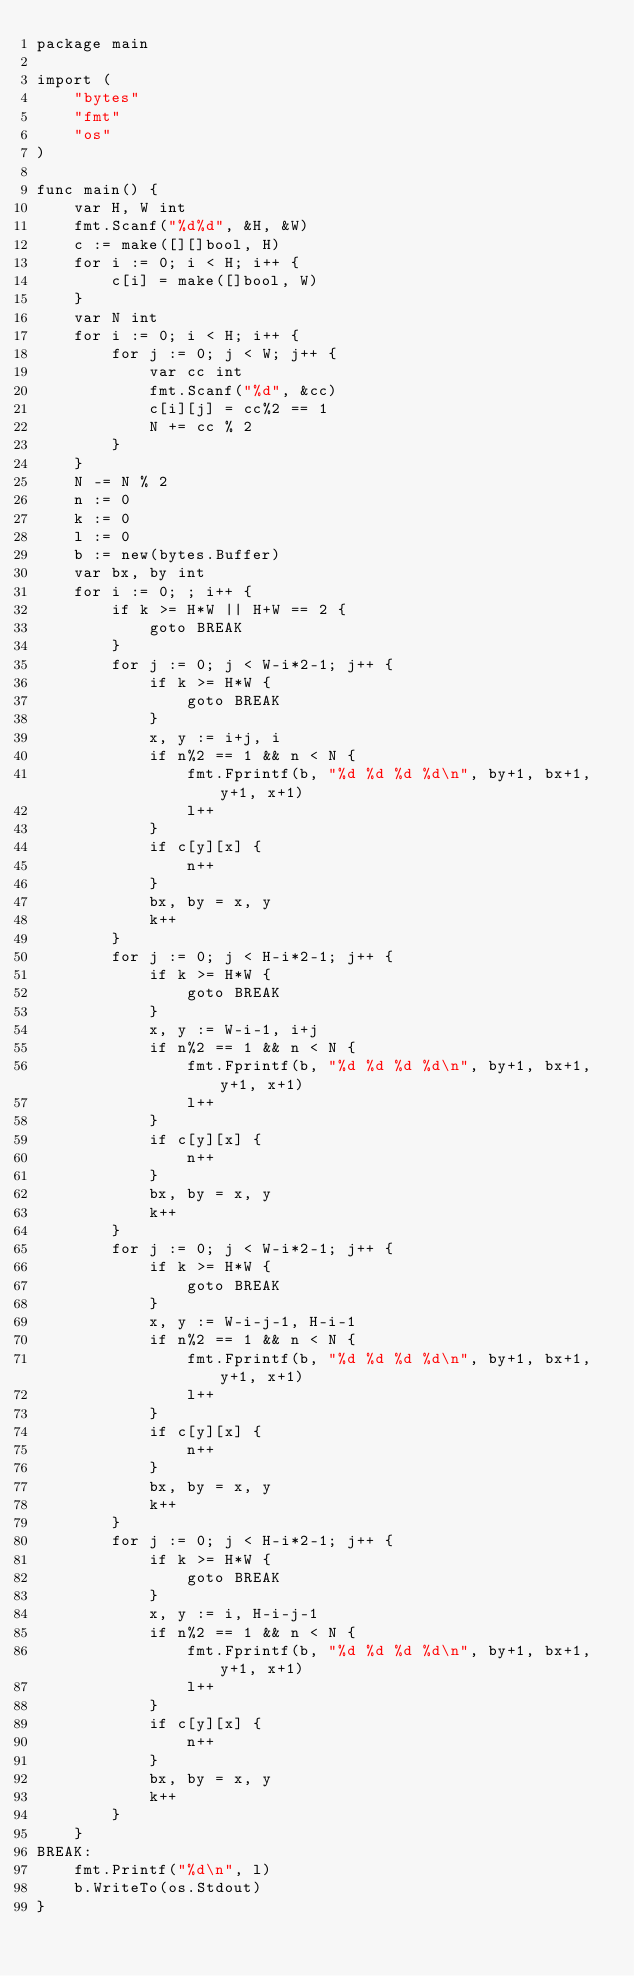<code> <loc_0><loc_0><loc_500><loc_500><_Go_>package main

import (
	"bytes"
	"fmt"
	"os"
)

func main() {
	var H, W int
	fmt.Scanf("%d%d", &H, &W)
	c := make([][]bool, H)
	for i := 0; i < H; i++ {
		c[i] = make([]bool, W)
	}
	var N int
	for i := 0; i < H; i++ {
		for j := 0; j < W; j++ {
			var cc int
			fmt.Scanf("%d", &cc)
			c[i][j] = cc%2 == 1
			N += cc % 2
		}
	}
	N -= N % 2
	n := 0
	k := 0
	l := 0
	b := new(bytes.Buffer)
	var bx, by int
	for i := 0; ; i++ {
		if k >= H*W || H+W == 2 {
			goto BREAK
		}
		for j := 0; j < W-i*2-1; j++ {
			if k >= H*W {
				goto BREAK
			}
			x, y := i+j, i
			if n%2 == 1 && n < N {
				fmt.Fprintf(b, "%d %d %d %d\n", by+1, bx+1, y+1, x+1)
				l++
			}
			if c[y][x] {
				n++
			}
			bx, by = x, y
			k++
		}
		for j := 0; j < H-i*2-1; j++ {
			if k >= H*W {
				goto BREAK
			}
			x, y := W-i-1, i+j
			if n%2 == 1 && n < N {
				fmt.Fprintf(b, "%d %d %d %d\n", by+1, bx+1, y+1, x+1)
				l++
			}
			if c[y][x] {
				n++
			}
			bx, by = x, y
			k++
		}
		for j := 0; j < W-i*2-1; j++ {
			if k >= H*W {
				goto BREAK
			}
			x, y := W-i-j-1, H-i-1
			if n%2 == 1 && n < N {
				fmt.Fprintf(b, "%d %d %d %d\n", by+1, bx+1, y+1, x+1)
				l++
			}
			if c[y][x] {
				n++
			}
			bx, by = x, y
			k++
		}
		for j := 0; j < H-i*2-1; j++ {
			if k >= H*W {
				goto BREAK
			}
			x, y := i, H-i-j-1
			if n%2 == 1 && n < N {
				fmt.Fprintf(b, "%d %d %d %d\n", by+1, bx+1, y+1, x+1)
				l++
			}
			if c[y][x] {
				n++
			}
			bx, by = x, y
			k++
		}
	}
BREAK:
	fmt.Printf("%d\n", l)
	b.WriteTo(os.Stdout)
}
</code> 